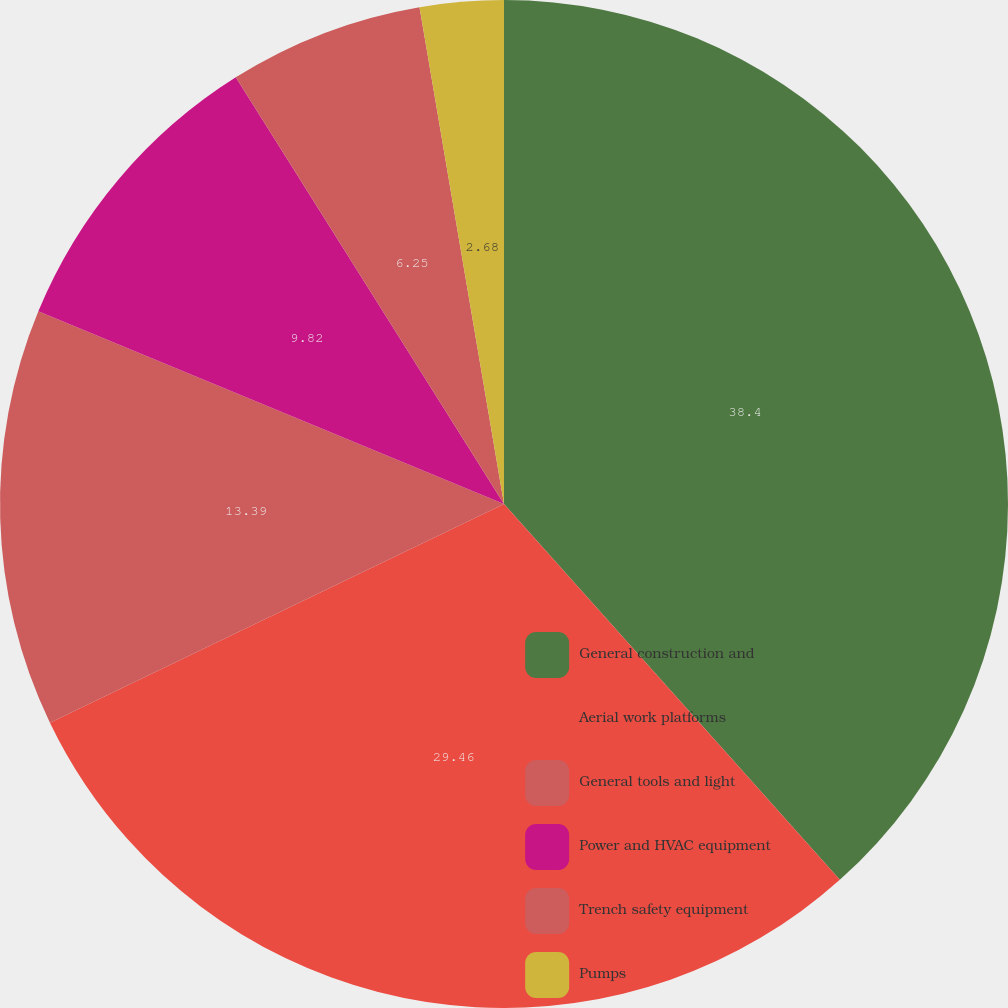Convert chart. <chart><loc_0><loc_0><loc_500><loc_500><pie_chart><fcel>General construction and<fcel>Aerial work platforms<fcel>General tools and light<fcel>Power and HVAC equipment<fcel>Trench safety equipment<fcel>Pumps<nl><fcel>38.39%<fcel>29.46%<fcel>13.39%<fcel>9.82%<fcel>6.25%<fcel>2.68%<nl></chart> 